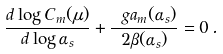<formula> <loc_0><loc_0><loc_500><loc_500>\frac { d \log C _ { m } ( \mu ) } { d \log \alpha _ { s } } + \frac { \ g a _ { m } ( \alpha _ { s } ) } { 2 \beta ( \alpha _ { s } ) } = 0 \, .</formula> 